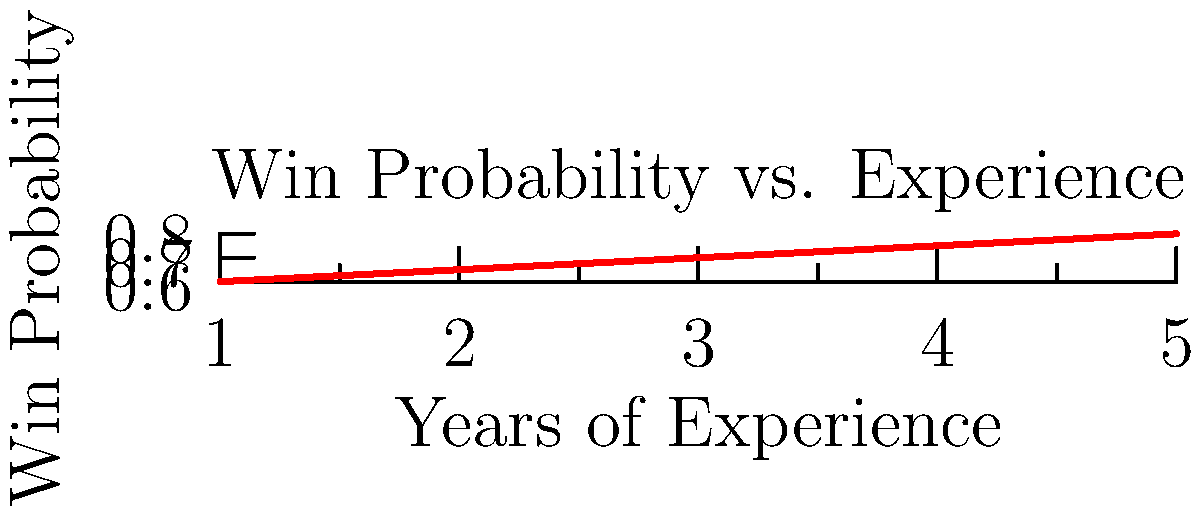Based on the graph showing a player's win probability over years of experience, if the player has been playing for 3.5 years, what is the estimated probability of winning their next match? Round your answer to two decimal places. To solve this problem, we need to interpolate between the given data points. Let's follow these steps:

1) Identify the two closest data points:
   - At 3 years: Win probability = 0.7
   - At 4 years: Win probability = 0.75

2) Calculate the rate of change between these points:
   $\frac{0.75 - 0.7}{4 - 3} = 0.05$ per year

3) The player has 3.5 years of experience, which is halfway between 3 and 4 years.

4) Calculate the increase in win probability for 0.5 years:
   $0.05 \times 0.5 = 0.025$

5) Add this increase to the win probability at 3 years:
   $0.7 + 0.025 = 0.725$

6) Round to two decimal places: 0.73

Therefore, the estimated probability of winning the next match is 0.73 or 73%.
Answer: 0.73 